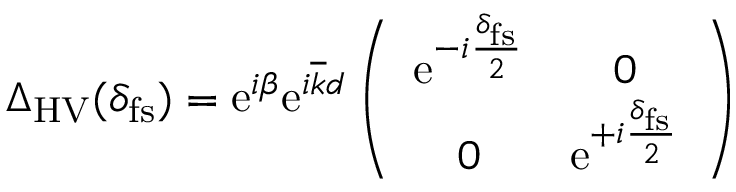Convert formula to latex. <formula><loc_0><loc_0><loc_500><loc_500>\begin{array} { r } { \Delta _ { H V } ( \delta _ { f s } ) = e ^ { i \beta } e ^ { i \overline { k } d } \left ( \begin{array} { c c } { e ^ { - i \frac { \delta _ { f s } } { 2 } } } & { 0 } \\ { 0 } & { e ^ { + i \frac { \delta _ { f s } } { 2 } } } \end{array} \right ) } \end{array}</formula> 